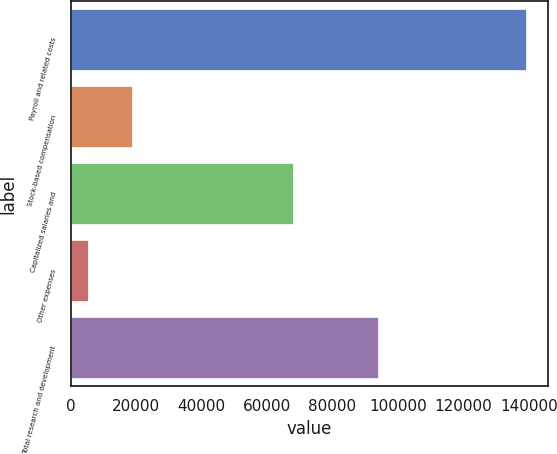Convert chart to OTSL. <chart><loc_0><loc_0><loc_500><loc_500><bar_chart><fcel>Payroll and related costs<fcel>Stock-based compensation<fcel>Capitalized salaries and<fcel>Other expenses<fcel>Total research and development<nl><fcel>139018<fcel>18693.4<fcel>67935<fcel>5324<fcel>93879<nl></chart> 